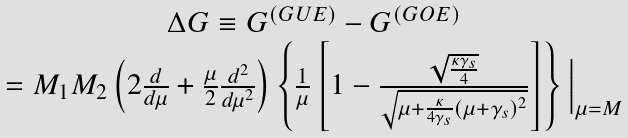<formula> <loc_0><loc_0><loc_500><loc_500>\begin{array} { c } \Delta G \equiv G ^ { ( G U E ) } - G ^ { ( G O E ) } \\ = M _ { 1 } M _ { 2 } \left ( 2 \frac { d } { d \mu } + \frac { \mu } { 2 } \frac { d ^ { 2 } } { d \mu ^ { 2 } } \right ) \left \{ \frac { 1 } { \mu } \left [ 1 - \frac { \sqrt { \frac { \kappa \gamma _ { s } } { 4 } } } { \sqrt { \mu + \frac { \kappa } { 4 \gamma _ { s } } ( \mu + \gamma _ { s } ) ^ { 2 } } } \right ] \right \} \Big | _ { \mu = M } \\ \end{array}</formula> 